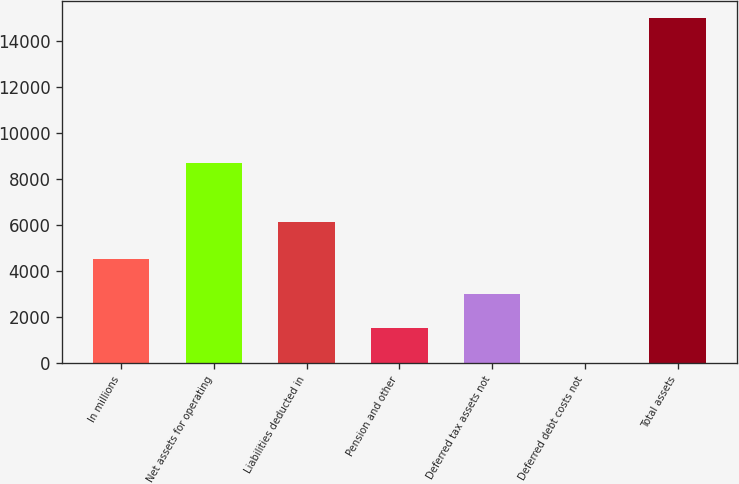<chart> <loc_0><loc_0><loc_500><loc_500><bar_chart><fcel>In millions<fcel>Net assets for operating<fcel>Liabilities deducted in<fcel>Pension and other<fcel>Deferred tax assets not<fcel>Deferred debt costs not<fcel>Total assets<nl><fcel>4504.7<fcel>8721<fcel>6152<fcel>1502.9<fcel>3003.8<fcel>2<fcel>15011<nl></chart> 